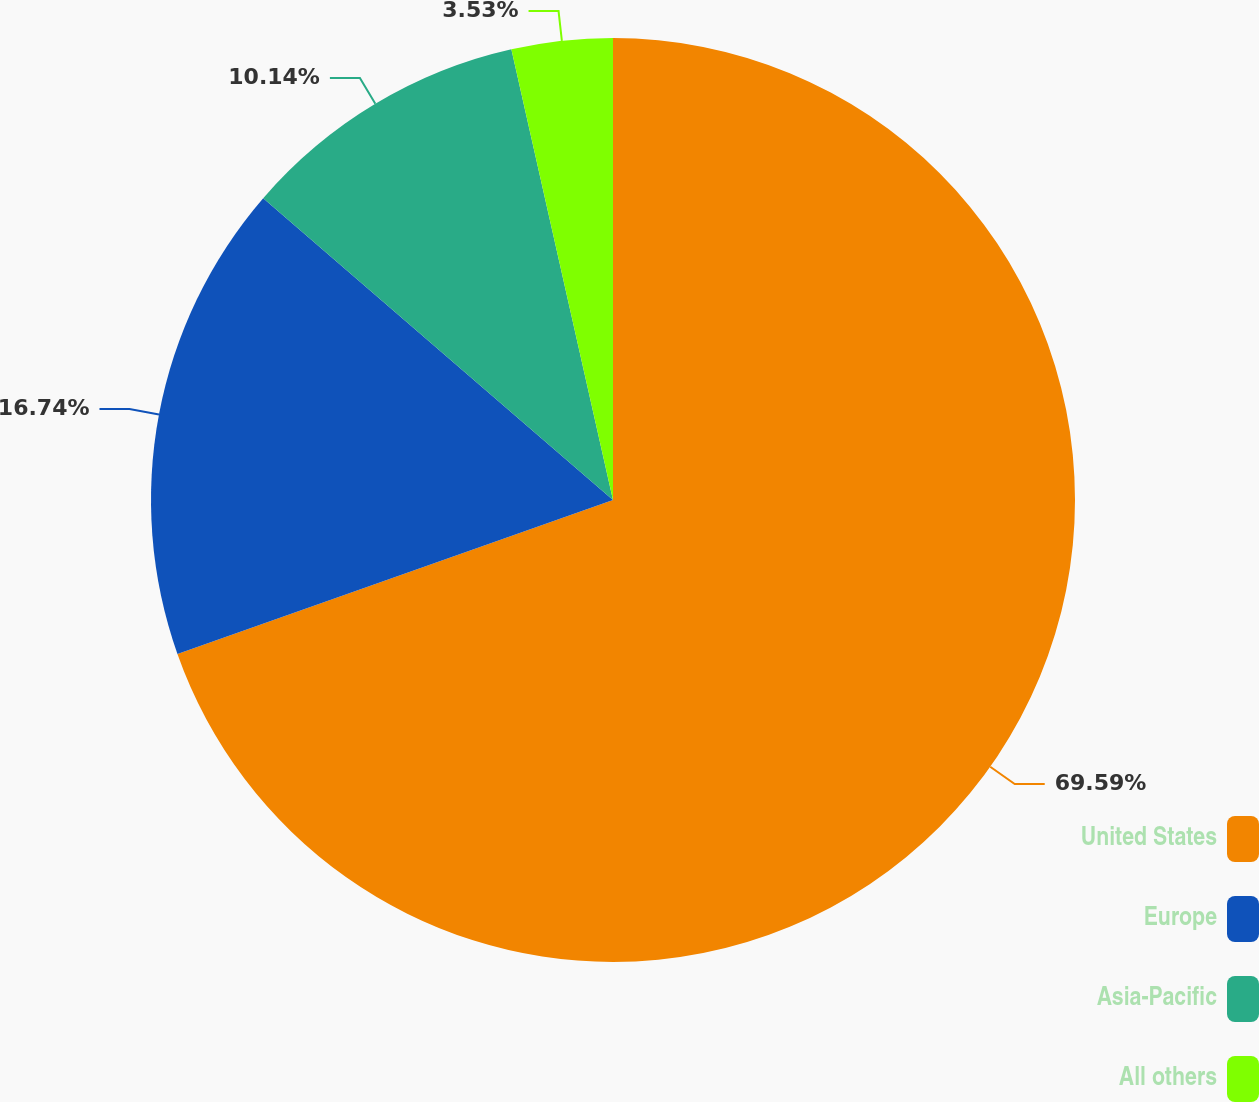Convert chart to OTSL. <chart><loc_0><loc_0><loc_500><loc_500><pie_chart><fcel>United States<fcel>Europe<fcel>Asia-Pacific<fcel>All others<nl><fcel>69.59%<fcel>16.74%<fcel>10.14%<fcel>3.53%<nl></chart> 